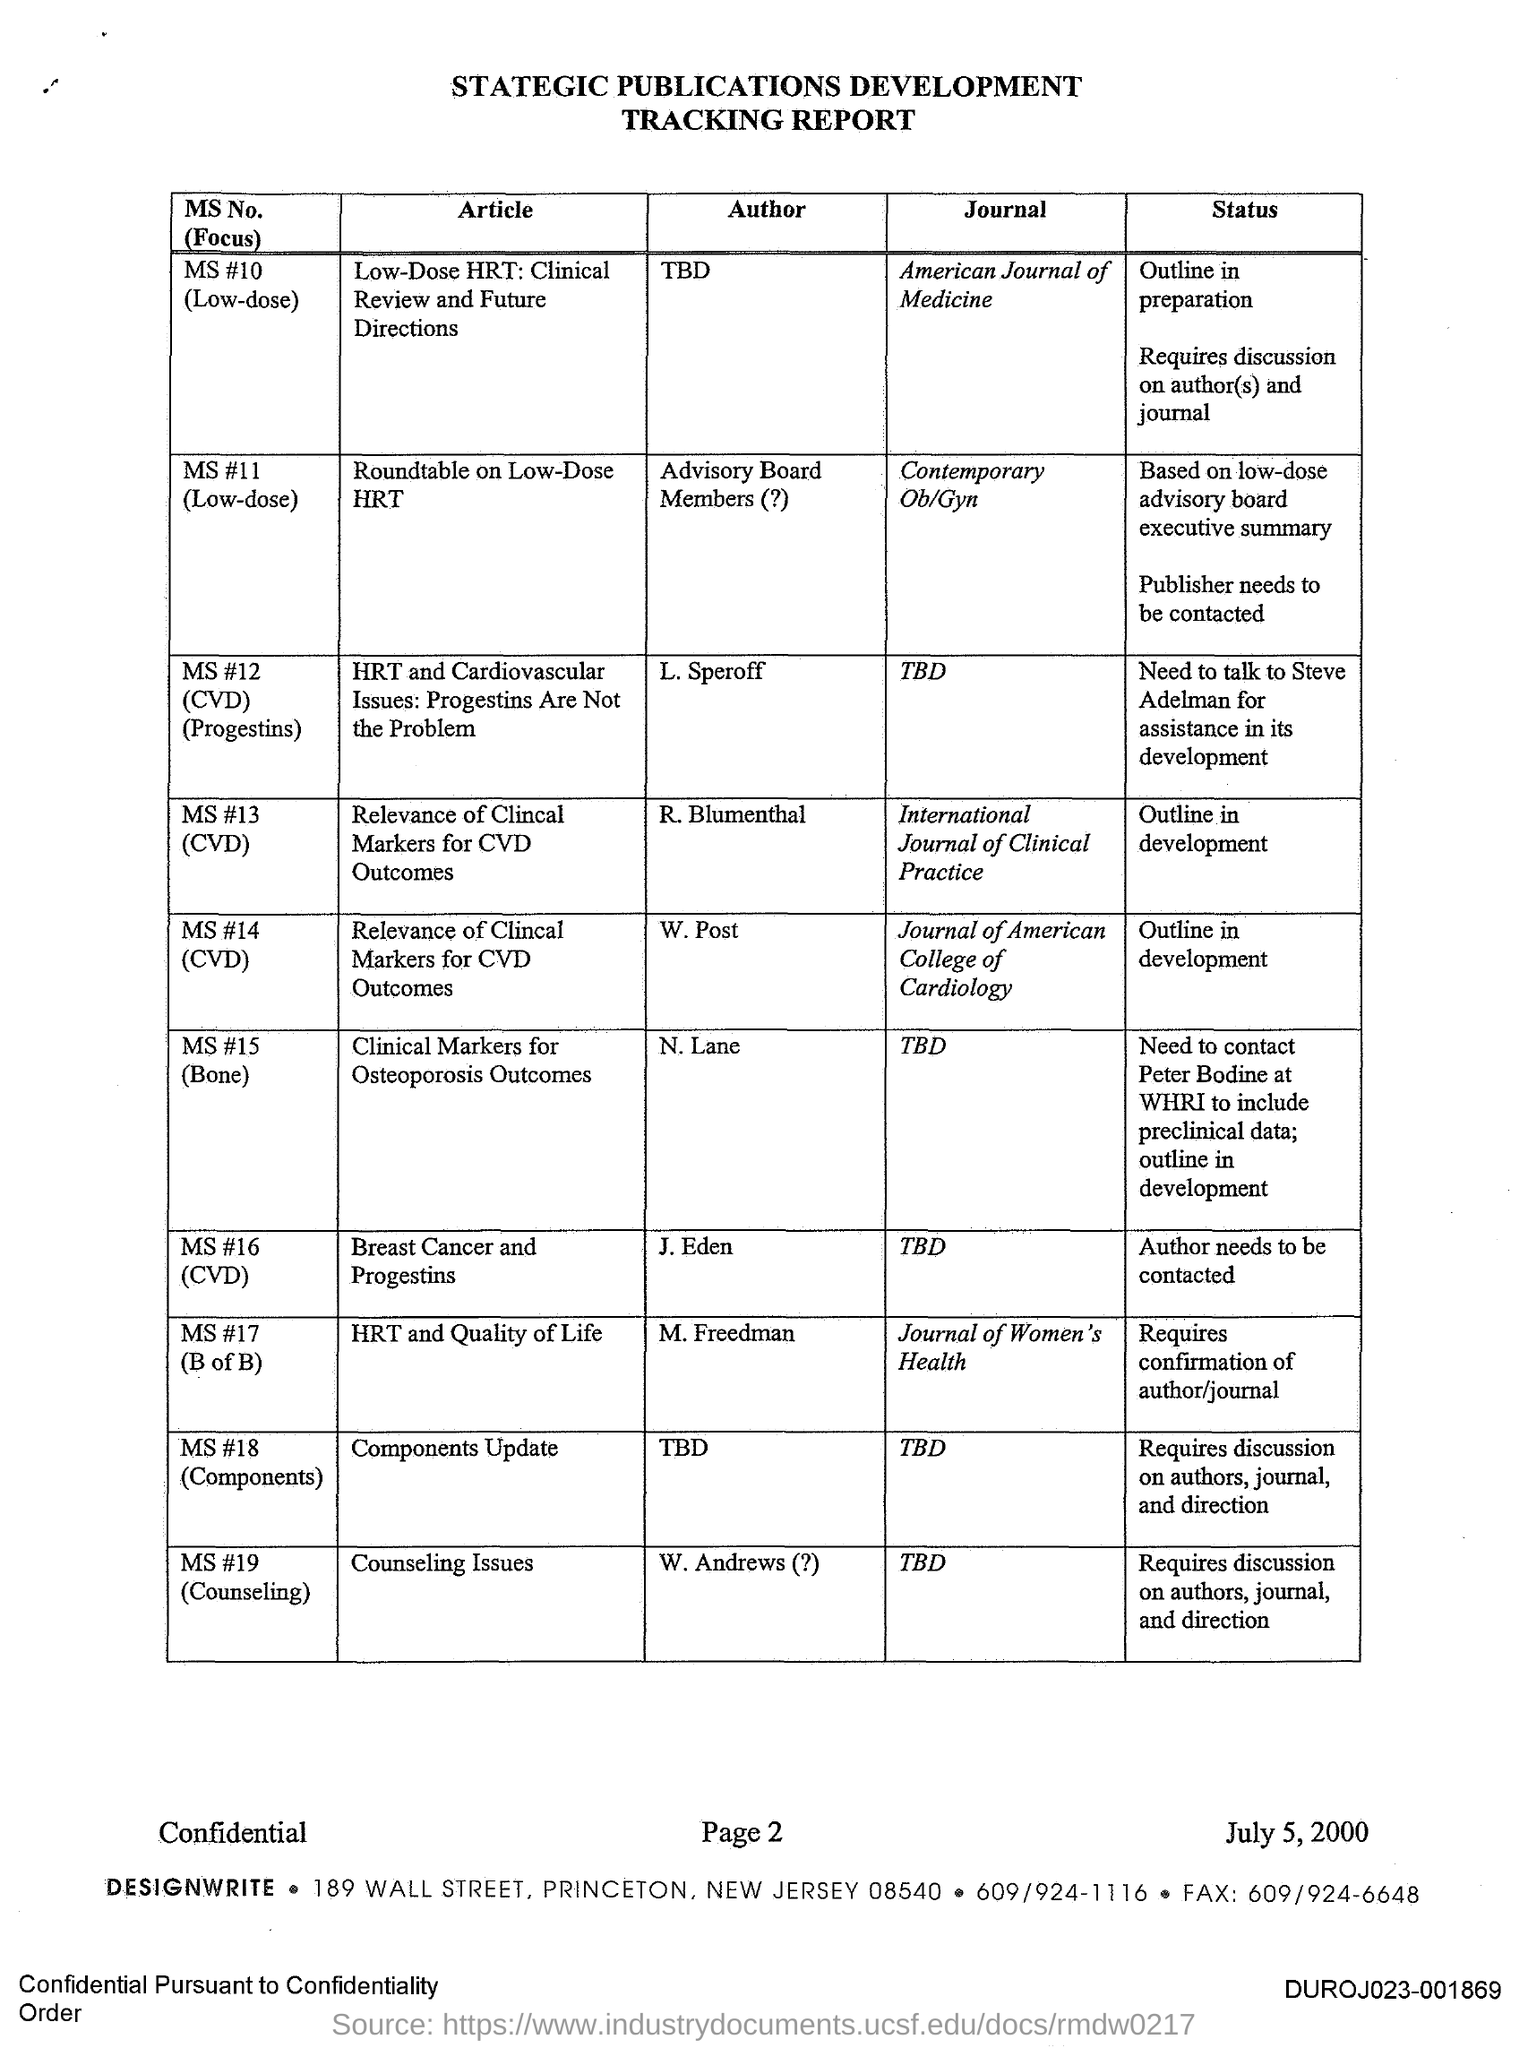In which journal, the article titled 'HRT and Quality of Life' is published?
 Journal of Women's Health 